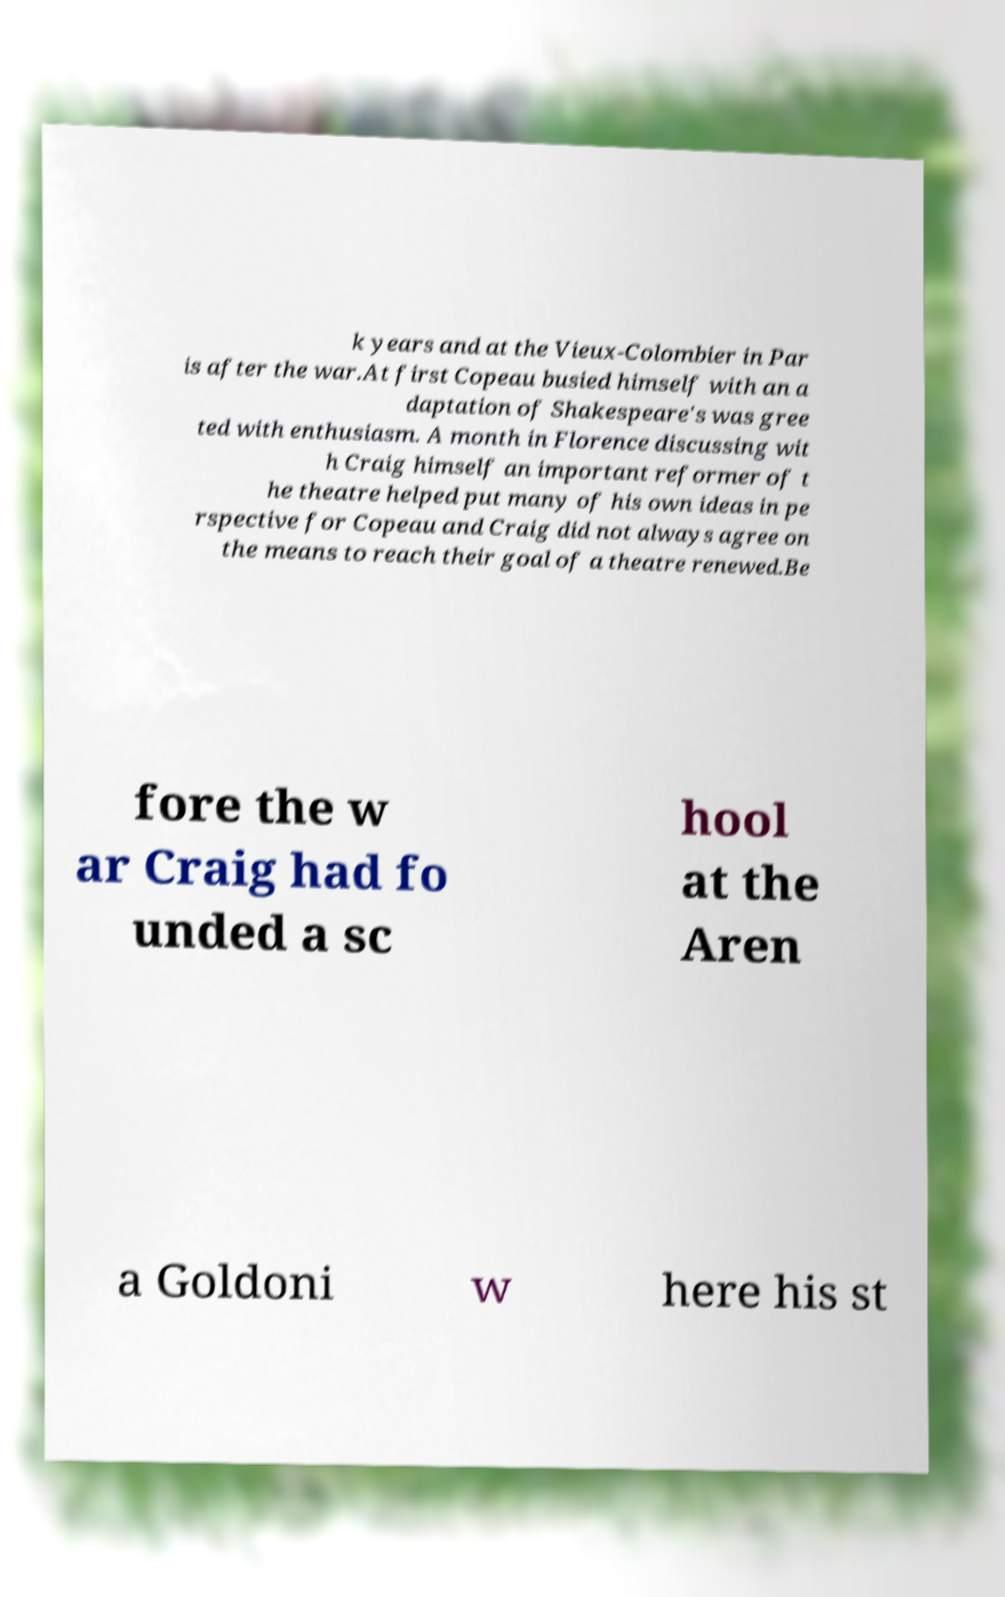There's text embedded in this image that I need extracted. Can you transcribe it verbatim? k years and at the Vieux-Colombier in Par is after the war.At first Copeau busied himself with an a daptation of Shakespeare's was gree ted with enthusiasm. A month in Florence discussing wit h Craig himself an important reformer of t he theatre helped put many of his own ideas in pe rspective for Copeau and Craig did not always agree on the means to reach their goal of a theatre renewed.Be fore the w ar Craig had fo unded a sc hool at the Aren a Goldoni w here his st 